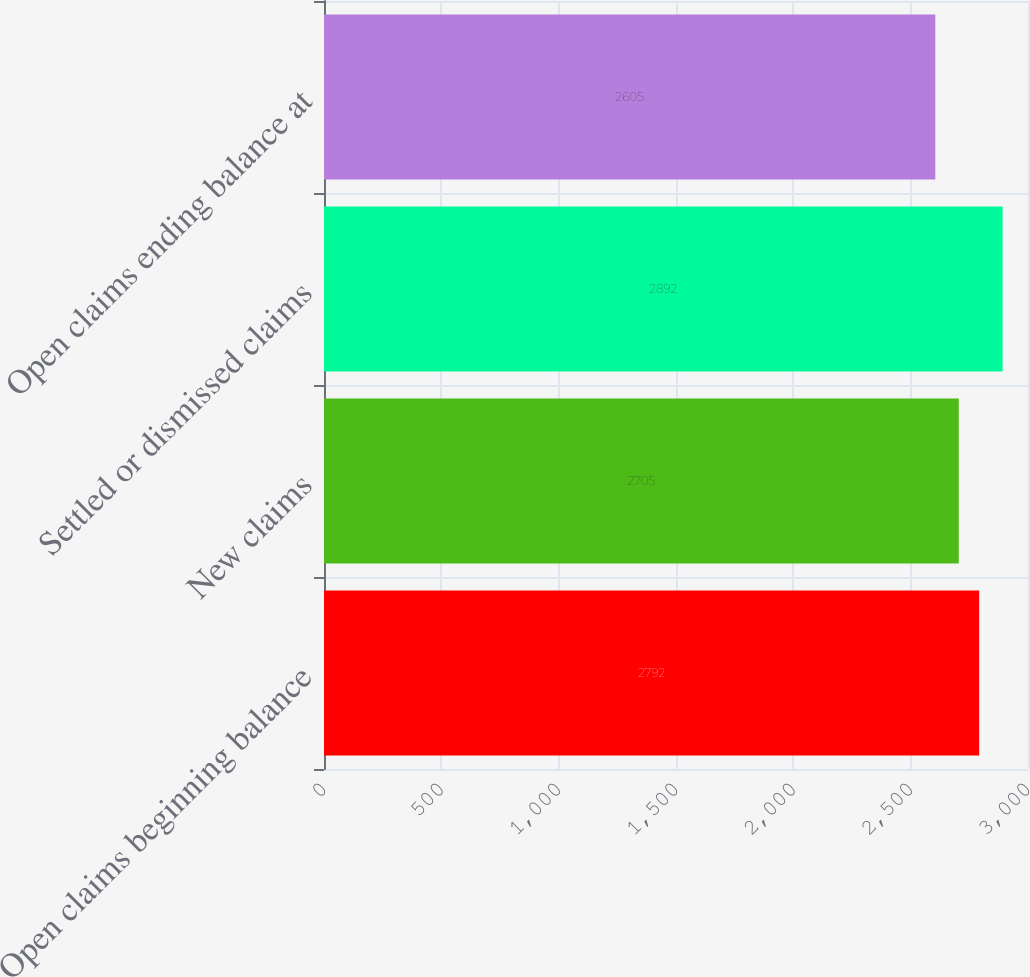Convert chart. <chart><loc_0><loc_0><loc_500><loc_500><bar_chart><fcel>Open claims beginning balance<fcel>New claims<fcel>Settled or dismissed claims<fcel>Open claims ending balance at<nl><fcel>2792<fcel>2705<fcel>2892<fcel>2605<nl></chart> 